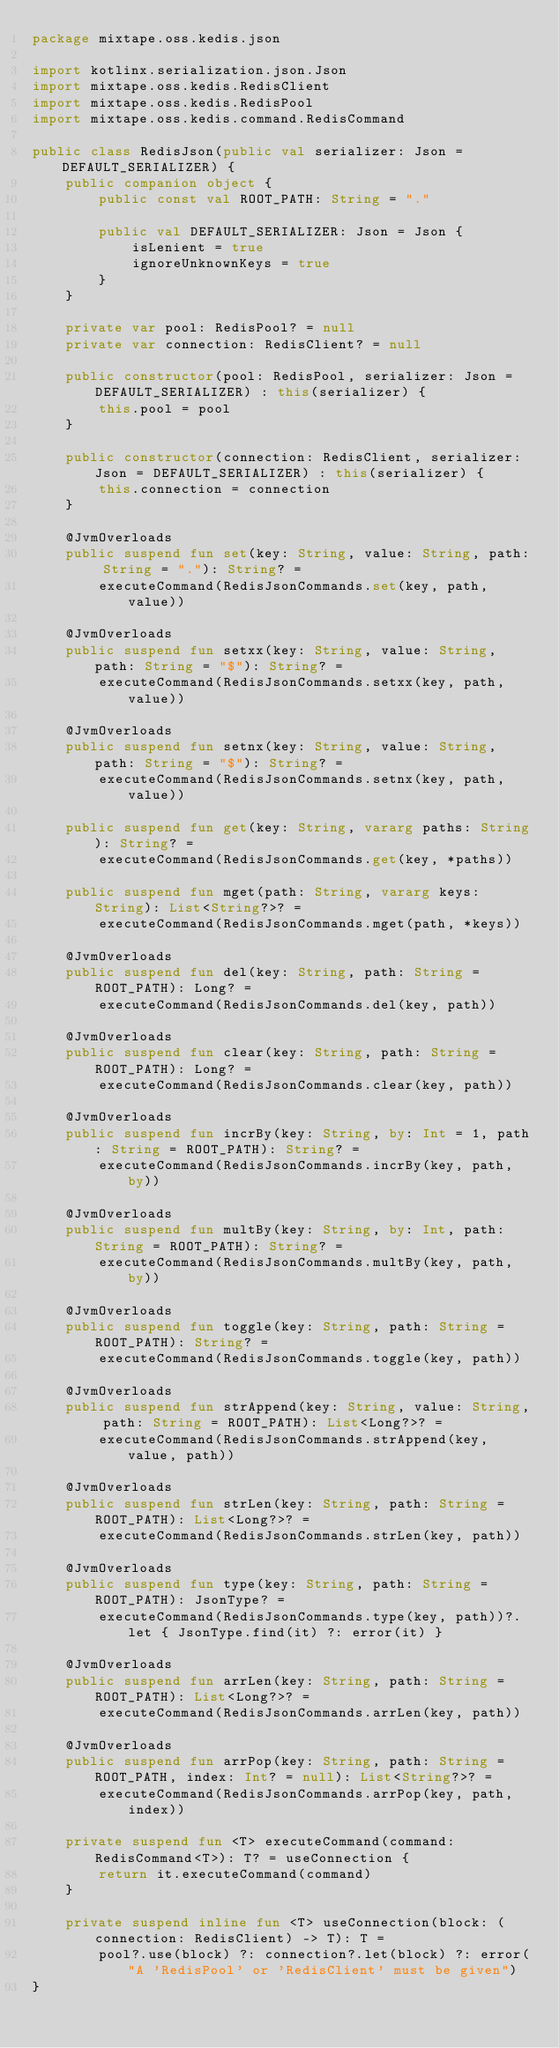Convert code to text. <code><loc_0><loc_0><loc_500><loc_500><_Kotlin_>package mixtape.oss.kedis.json

import kotlinx.serialization.json.Json
import mixtape.oss.kedis.RedisClient
import mixtape.oss.kedis.RedisPool
import mixtape.oss.kedis.command.RedisCommand

public class RedisJson(public val serializer: Json = DEFAULT_SERIALIZER) {
    public companion object {
        public const val ROOT_PATH: String = "."

        public val DEFAULT_SERIALIZER: Json = Json {
            isLenient = true
            ignoreUnknownKeys = true
        }
    }

    private var pool: RedisPool? = null
    private var connection: RedisClient? = null

    public constructor(pool: RedisPool, serializer: Json = DEFAULT_SERIALIZER) : this(serializer) {
        this.pool = pool
    }

    public constructor(connection: RedisClient, serializer: Json = DEFAULT_SERIALIZER) : this(serializer) {
        this.connection = connection
    }

    @JvmOverloads
    public suspend fun set(key: String, value: String, path: String = "."): String? =
        executeCommand(RedisJsonCommands.set(key, path, value))

    @JvmOverloads
    public suspend fun setxx(key: String, value: String, path: String = "$"): String? =
        executeCommand(RedisJsonCommands.setxx(key, path, value))

    @JvmOverloads
    public suspend fun setnx(key: String, value: String, path: String = "$"): String? =
        executeCommand(RedisJsonCommands.setnx(key, path, value))

    public suspend fun get(key: String, vararg paths: String): String? =
        executeCommand(RedisJsonCommands.get(key, *paths))

    public suspend fun mget(path: String, vararg keys: String): List<String?>? =
        executeCommand(RedisJsonCommands.mget(path, *keys))

    @JvmOverloads
    public suspend fun del(key: String, path: String = ROOT_PATH): Long? =
        executeCommand(RedisJsonCommands.del(key, path))

    @JvmOverloads
    public suspend fun clear(key: String, path: String = ROOT_PATH): Long? =
        executeCommand(RedisJsonCommands.clear(key, path))

    @JvmOverloads
    public suspend fun incrBy(key: String, by: Int = 1, path: String = ROOT_PATH): String? =
        executeCommand(RedisJsonCommands.incrBy(key, path, by))

    @JvmOverloads
    public suspend fun multBy(key: String, by: Int, path: String = ROOT_PATH): String? =
        executeCommand(RedisJsonCommands.multBy(key, path, by))

    @JvmOverloads
    public suspend fun toggle(key: String, path: String = ROOT_PATH): String? =
        executeCommand(RedisJsonCommands.toggle(key, path))

    @JvmOverloads
    public suspend fun strAppend(key: String, value: String, path: String = ROOT_PATH): List<Long?>? =
        executeCommand(RedisJsonCommands.strAppend(key, value, path))

    @JvmOverloads
    public suspend fun strLen(key: String, path: String = ROOT_PATH): List<Long?>? =
        executeCommand(RedisJsonCommands.strLen(key, path))

    @JvmOverloads
    public suspend fun type(key: String, path: String = ROOT_PATH): JsonType? =
        executeCommand(RedisJsonCommands.type(key, path))?.let { JsonType.find(it) ?: error(it) }

    @JvmOverloads
    public suspend fun arrLen(key: String, path: String = ROOT_PATH): List<Long?>? =
        executeCommand(RedisJsonCommands.arrLen(key, path))

    @JvmOverloads
    public suspend fun arrPop(key: String, path: String = ROOT_PATH, index: Int? = null): List<String?>? =
        executeCommand(RedisJsonCommands.arrPop(key, path, index))

    private suspend fun <T> executeCommand(command: RedisCommand<T>): T? = useConnection {
        return it.executeCommand(command)
    }

    private suspend inline fun <T> useConnection(block: (connection: RedisClient) -> T): T =
        pool?.use(block) ?: connection?.let(block) ?: error("A 'RedisPool' or 'RedisClient' must be given")
}
</code> 